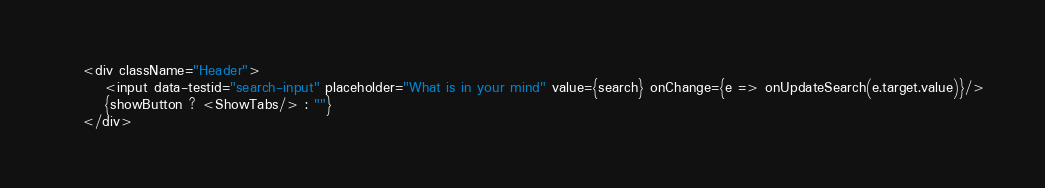Convert code to text. <code><loc_0><loc_0><loc_500><loc_500><_TypeScript_>    <div className="Header">
        <input data-testid="search-input" placeholder="What is in your mind" value={search} onChange={e => onUpdateSearch(e.target.value)}/>
        {showButton ? <ShowTabs/> : ""}
    </div></code> 